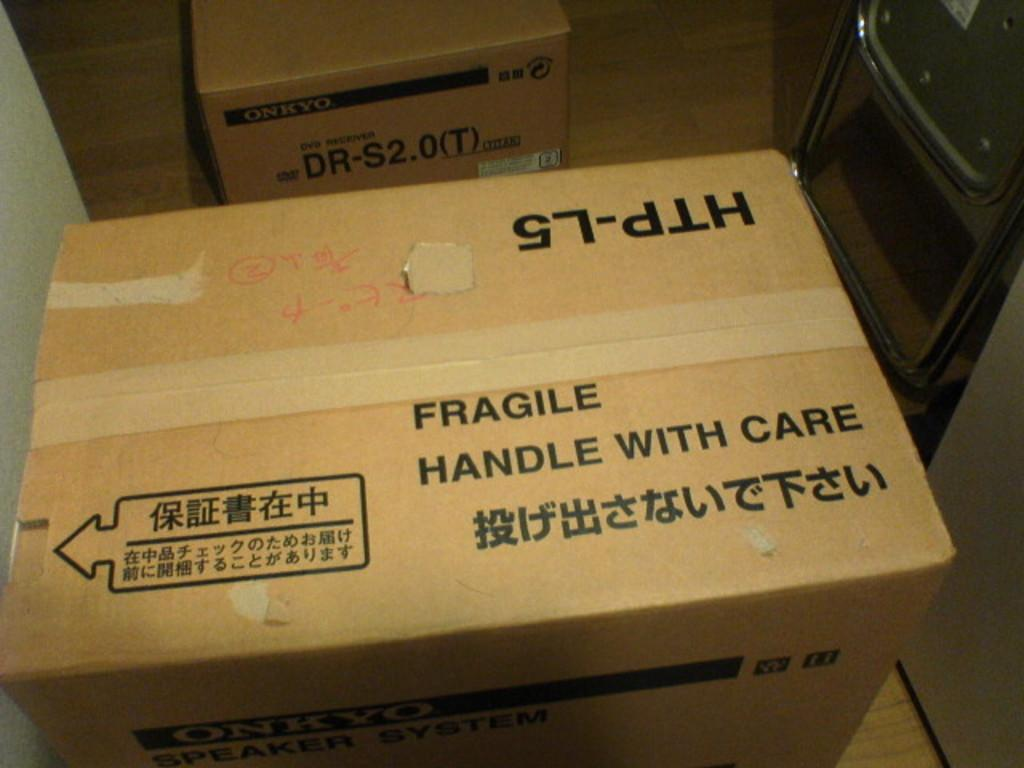Provide a one-sentence caption for the provided image. cardboard box with the word fragile written across. 